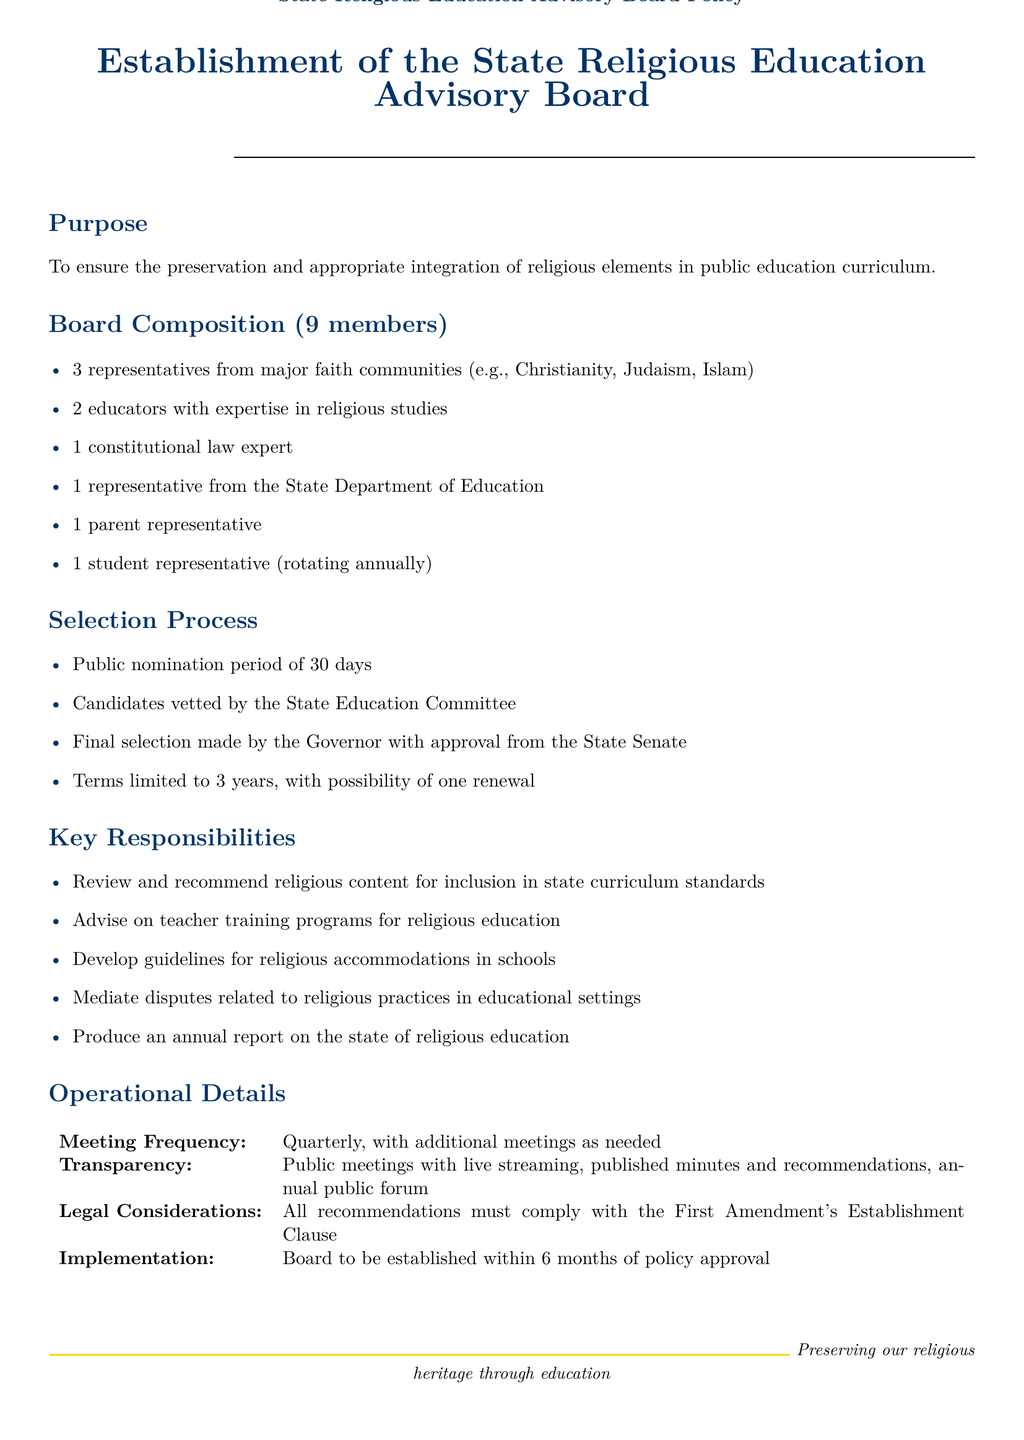What is the purpose of the State Religious Education Advisory Board? The purpose is to ensure the preservation and appropriate integration of religious elements in public education curriculum.
Answer: To ensure the preservation and appropriate integration of religious elements in public education curriculum How many members are on the board? The document states that there are 9 members on the board.
Answer: 9 members Who selects the candidates for the board? The final selection of candidates is made by the Governor with approval from the State Senate.
Answer: The Governor with approval from the State Senate What is the term limit for board members? The term limit for board members is 3 years, with the possibility of one renewal.
Answer: 3 years How often does the board meet? The board meets quarterly, with additional meetings as needed.
Answer: Quarterly What kind of expert is required on the board? The document specifies that there should be one constitutional law expert on the board.
Answer: One constitutional law expert What is one of the key responsibilities of the board? The board is responsible for reviewing and recommending religious content for inclusion in state curriculum standards.
Answer: Review and recommend religious content for inclusion in state curriculum standards What ensures the meetings of the board are transparent? The document mentions public meetings with live streaming and published minutes and recommendations as transparency measures.
Answer: Public meetings with live streaming, published minutes and recommendations What must all recommendations comply with? All recommendations must comply with the First Amendment's Establishment Clause.
Answer: First Amendment's Establishment Clause 